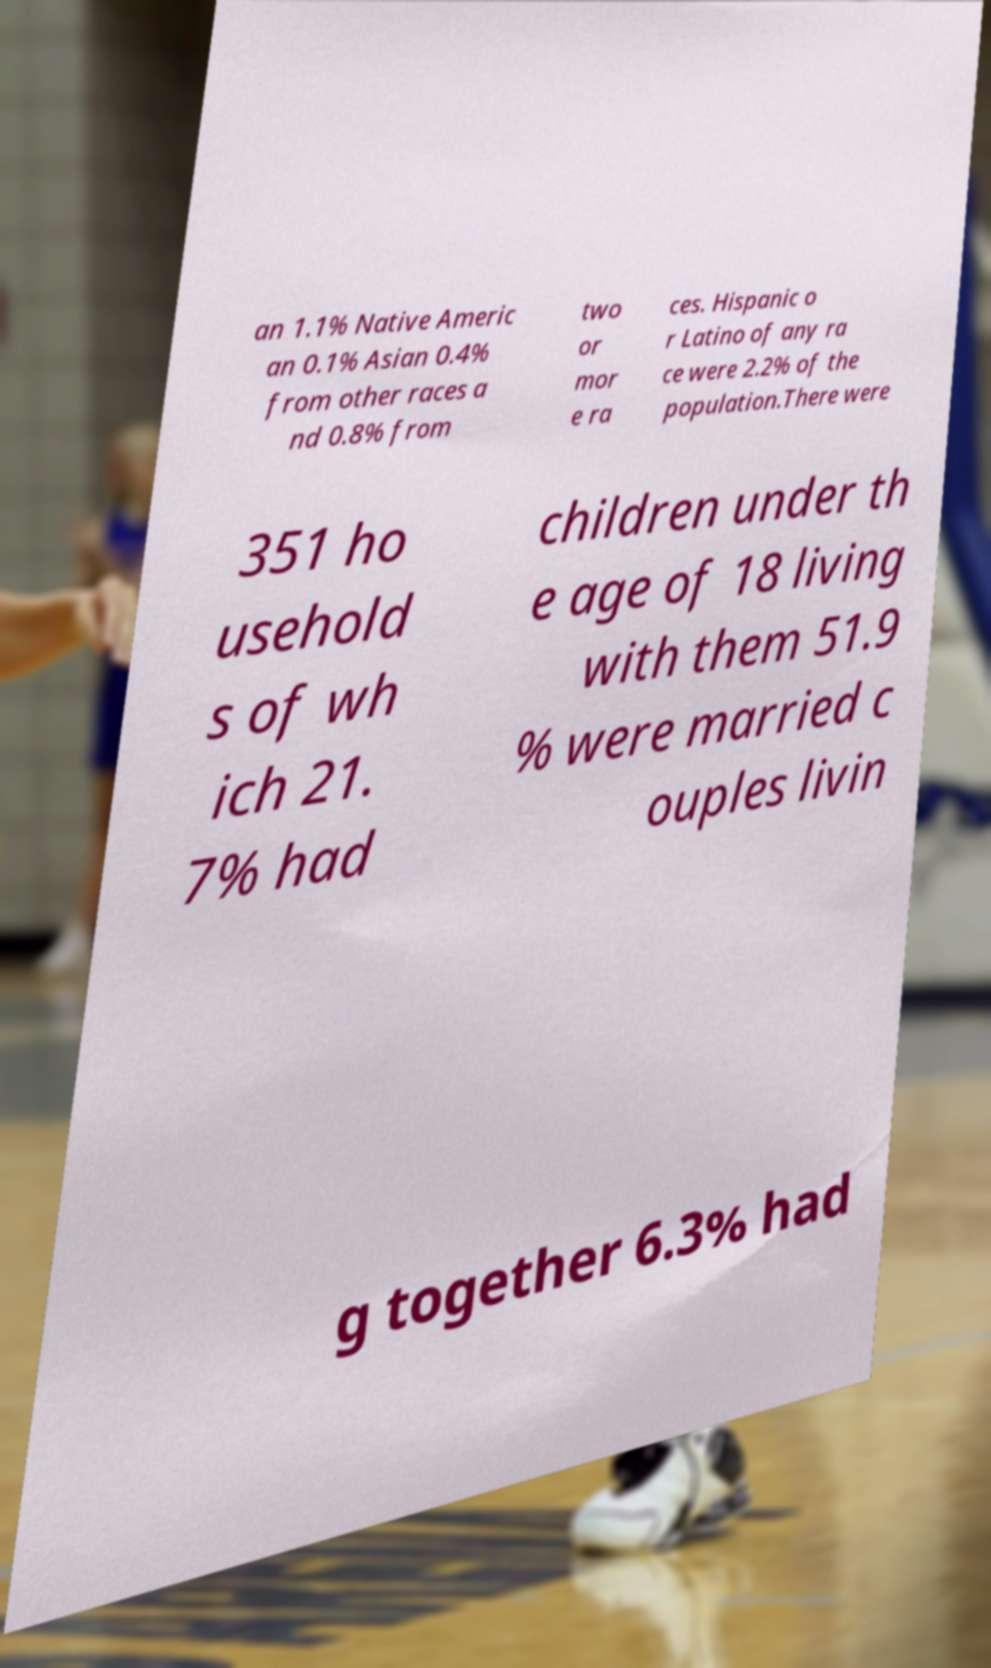Can you read and provide the text displayed in the image?This photo seems to have some interesting text. Can you extract and type it out for me? an 1.1% Native Americ an 0.1% Asian 0.4% from other races a nd 0.8% from two or mor e ra ces. Hispanic o r Latino of any ra ce were 2.2% of the population.There were 351 ho usehold s of wh ich 21. 7% had children under th e age of 18 living with them 51.9 % were married c ouples livin g together 6.3% had 